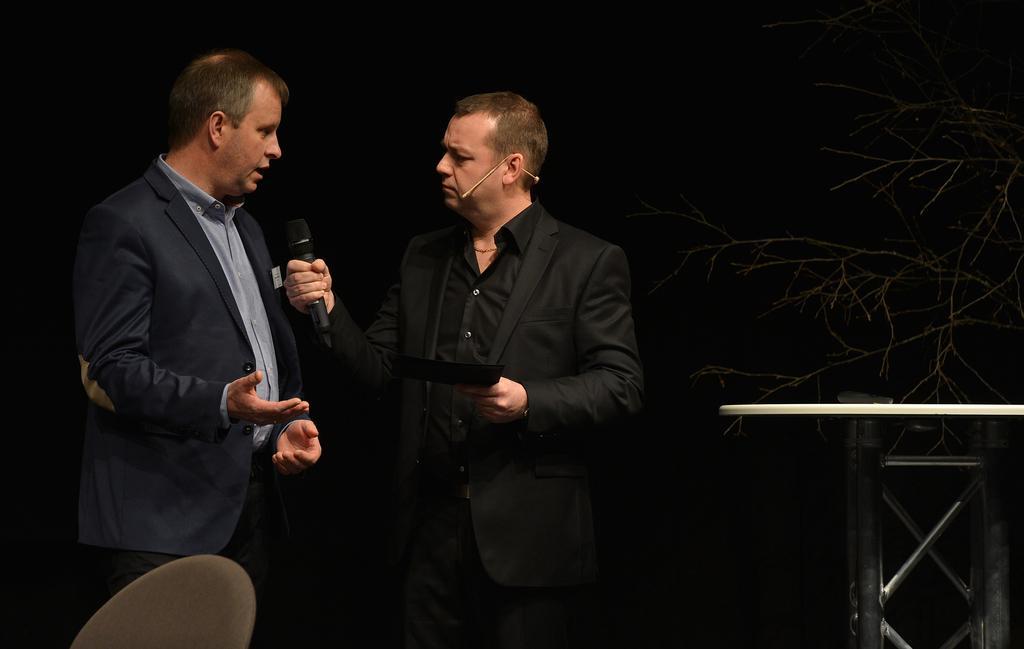Please provide a concise description of this image. Here in this picture we can see two men standing over a place and we can see both of them are wearing suits on them and the person on the right side is holding a card and a microphone in his hand and the person on the left side is speaking something in the microphone present in front of him and we can also see a tree, a table and a chair present over there. 